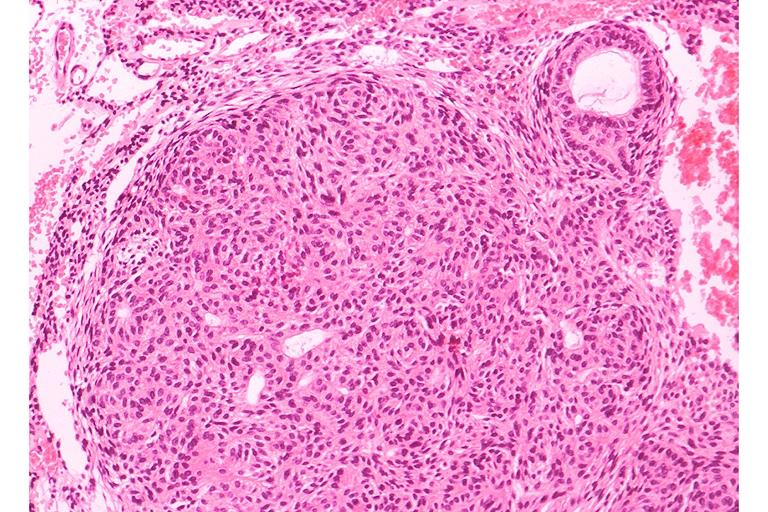where is this?
Answer the question using a single word or phrase. Oral 